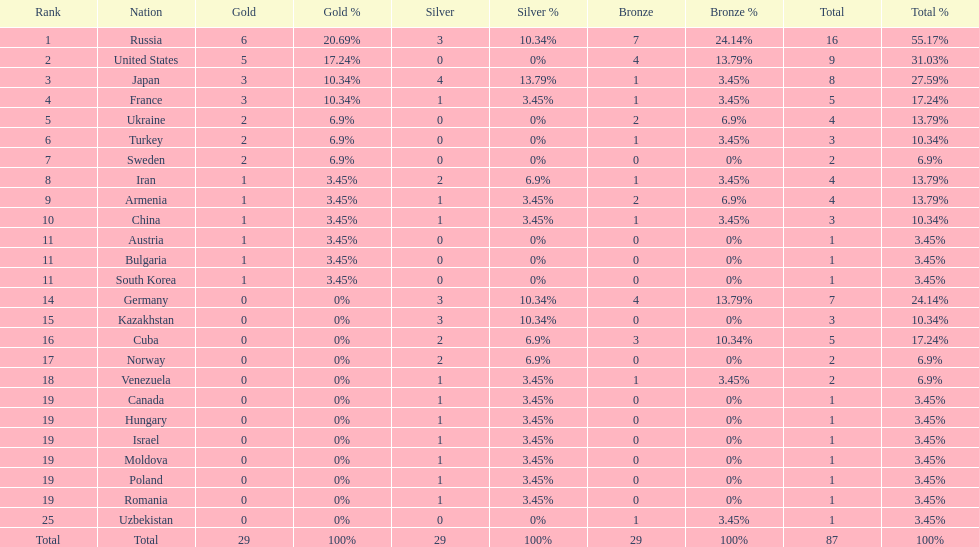How many silver medals did turkey win? 0. 